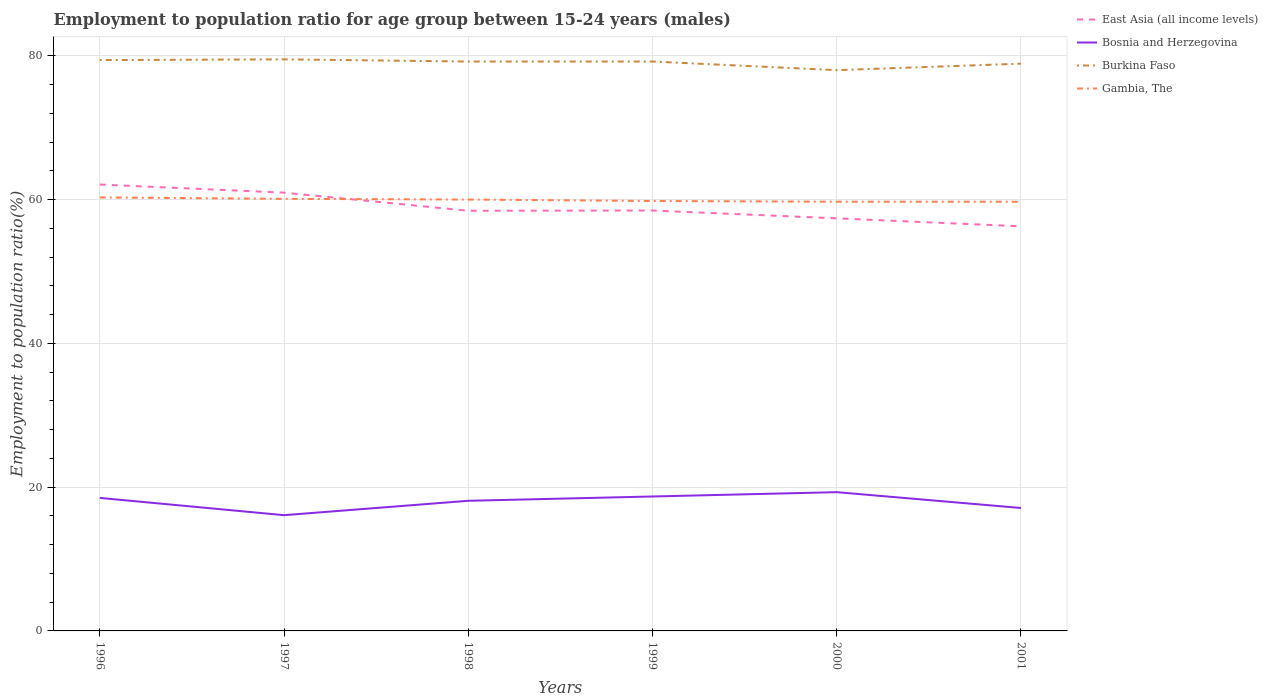How many different coloured lines are there?
Make the answer very short. 4. Across all years, what is the maximum employment to population ratio in Burkina Faso?
Your answer should be very brief. 78. What is the total employment to population ratio in East Asia (all income levels) in the graph?
Your response must be concise. 2.49. What is the difference between the highest and the second highest employment to population ratio in Bosnia and Herzegovina?
Give a very brief answer. 3.2. What is the difference between two consecutive major ticks on the Y-axis?
Ensure brevity in your answer.  20. Are the values on the major ticks of Y-axis written in scientific E-notation?
Ensure brevity in your answer.  No. Does the graph contain any zero values?
Your answer should be very brief. No. Does the graph contain grids?
Your answer should be very brief. Yes. Where does the legend appear in the graph?
Your answer should be compact. Top right. How many legend labels are there?
Your answer should be very brief. 4. How are the legend labels stacked?
Keep it short and to the point. Vertical. What is the title of the graph?
Your response must be concise. Employment to population ratio for age group between 15-24 years (males). What is the label or title of the Y-axis?
Offer a terse response. Employment to population ratio(%). What is the Employment to population ratio(%) in East Asia (all income levels) in 1996?
Provide a succinct answer. 62.09. What is the Employment to population ratio(%) in Burkina Faso in 1996?
Your response must be concise. 79.4. What is the Employment to population ratio(%) in Gambia, The in 1996?
Provide a succinct answer. 60.3. What is the Employment to population ratio(%) of East Asia (all income levels) in 1997?
Your answer should be very brief. 60.96. What is the Employment to population ratio(%) of Bosnia and Herzegovina in 1997?
Offer a very short reply. 16.1. What is the Employment to population ratio(%) of Burkina Faso in 1997?
Offer a terse response. 79.5. What is the Employment to population ratio(%) in Gambia, The in 1997?
Make the answer very short. 60.1. What is the Employment to population ratio(%) of East Asia (all income levels) in 1998?
Keep it short and to the point. 58.44. What is the Employment to population ratio(%) in Bosnia and Herzegovina in 1998?
Make the answer very short. 18.1. What is the Employment to population ratio(%) of Burkina Faso in 1998?
Provide a succinct answer. 79.2. What is the Employment to population ratio(%) of Gambia, The in 1998?
Provide a succinct answer. 60. What is the Employment to population ratio(%) of East Asia (all income levels) in 1999?
Provide a short and direct response. 58.47. What is the Employment to population ratio(%) in Bosnia and Herzegovina in 1999?
Your response must be concise. 18.7. What is the Employment to population ratio(%) of Burkina Faso in 1999?
Keep it short and to the point. 79.2. What is the Employment to population ratio(%) of Gambia, The in 1999?
Offer a very short reply. 59.8. What is the Employment to population ratio(%) of East Asia (all income levels) in 2000?
Provide a succinct answer. 57.39. What is the Employment to population ratio(%) of Bosnia and Herzegovina in 2000?
Give a very brief answer. 19.3. What is the Employment to population ratio(%) in Gambia, The in 2000?
Provide a succinct answer. 59.7. What is the Employment to population ratio(%) in East Asia (all income levels) in 2001?
Give a very brief answer. 56.28. What is the Employment to population ratio(%) of Bosnia and Herzegovina in 2001?
Make the answer very short. 17.1. What is the Employment to population ratio(%) in Burkina Faso in 2001?
Ensure brevity in your answer.  78.9. What is the Employment to population ratio(%) in Gambia, The in 2001?
Your response must be concise. 59.7. Across all years, what is the maximum Employment to population ratio(%) in East Asia (all income levels)?
Make the answer very short. 62.09. Across all years, what is the maximum Employment to population ratio(%) in Bosnia and Herzegovina?
Offer a very short reply. 19.3. Across all years, what is the maximum Employment to population ratio(%) of Burkina Faso?
Ensure brevity in your answer.  79.5. Across all years, what is the maximum Employment to population ratio(%) of Gambia, The?
Your answer should be very brief. 60.3. Across all years, what is the minimum Employment to population ratio(%) of East Asia (all income levels)?
Provide a succinct answer. 56.28. Across all years, what is the minimum Employment to population ratio(%) in Bosnia and Herzegovina?
Ensure brevity in your answer.  16.1. Across all years, what is the minimum Employment to population ratio(%) of Gambia, The?
Your response must be concise. 59.7. What is the total Employment to population ratio(%) of East Asia (all income levels) in the graph?
Your answer should be very brief. 353.63. What is the total Employment to population ratio(%) of Bosnia and Herzegovina in the graph?
Your answer should be very brief. 107.8. What is the total Employment to population ratio(%) of Burkina Faso in the graph?
Your answer should be very brief. 474.2. What is the total Employment to population ratio(%) in Gambia, The in the graph?
Provide a short and direct response. 359.6. What is the difference between the Employment to population ratio(%) in East Asia (all income levels) in 1996 and that in 1997?
Make the answer very short. 1.13. What is the difference between the Employment to population ratio(%) of Bosnia and Herzegovina in 1996 and that in 1997?
Offer a terse response. 2.4. What is the difference between the Employment to population ratio(%) of Burkina Faso in 1996 and that in 1997?
Make the answer very short. -0.1. What is the difference between the Employment to population ratio(%) in East Asia (all income levels) in 1996 and that in 1998?
Provide a succinct answer. 3.65. What is the difference between the Employment to population ratio(%) of Bosnia and Herzegovina in 1996 and that in 1998?
Your answer should be very brief. 0.4. What is the difference between the Employment to population ratio(%) in East Asia (all income levels) in 1996 and that in 1999?
Your answer should be very brief. 3.62. What is the difference between the Employment to population ratio(%) of Burkina Faso in 1996 and that in 1999?
Provide a short and direct response. 0.2. What is the difference between the Employment to population ratio(%) in East Asia (all income levels) in 1996 and that in 2000?
Provide a succinct answer. 4.7. What is the difference between the Employment to population ratio(%) in Gambia, The in 1996 and that in 2000?
Provide a short and direct response. 0.6. What is the difference between the Employment to population ratio(%) of East Asia (all income levels) in 1996 and that in 2001?
Your answer should be very brief. 5.81. What is the difference between the Employment to population ratio(%) of Gambia, The in 1996 and that in 2001?
Your answer should be compact. 0.6. What is the difference between the Employment to population ratio(%) in East Asia (all income levels) in 1997 and that in 1998?
Provide a succinct answer. 2.52. What is the difference between the Employment to population ratio(%) of East Asia (all income levels) in 1997 and that in 1999?
Your answer should be compact. 2.49. What is the difference between the Employment to population ratio(%) in Burkina Faso in 1997 and that in 1999?
Your response must be concise. 0.3. What is the difference between the Employment to population ratio(%) in Gambia, The in 1997 and that in 1999?
Provide a short and direct response. 0.3. What is the difference between the Employment to population ratio(%) of East Asia (all income levels) in 1997 and that in 2000?
Ensure brevity in your answer.  3.57. What is the difference between the Employment to population ratio(%) of Burkina Faso in 1997 and that in 2000?
Provide a succinct answer. 1.5. What is the difference between the Employment to population ratio(%) of East Asia (all income levels) in 1997 and that in 2001?
Ensure brevity in your answer.  4.68. What is the difference between the Employment to population ratio(%) of Bosnia and Herzegovina in 1997 and that in 2001?
Make the answer very short. -1. What is the difference between the Employment to population ratio(%) in East Asia (all income levels) in 1998 and that in 1999?
Your answer should be very brief. -0.03. What is the difference between the Employment to population ratio(%) in East Asia (all income levels) in 1998 and that in 2000?
Give a very brief answer. 1.06. What is the difference between the Employment to population ratio(%) in Bosnia and Herzegovina in 1998 and that in 2000?
Offer a very short reply. -1.2. What is the difference between the Employment to population ratio(%) in East Asia (all income levels) in 1998 and that in 2001?
Keep it short and to the point. 2.17. What is the difference between the Employment to population ratio(%) in Burkina Faso in 1998 and that in 2001?
Provide a short and direct response. 0.3. What is the difference between the Employment to population ratio(%) in Gambia, The in 1998 and that in 2001?
Your response must be concise. 0.3. What is the difference between the Employment to population ratio(%) of East Asia (all income levels) in 1999 and that in 2000?
Give a very brief answer. 1.09. What is the difference between the Employment to population ratio(%) of Burkina Faso in 1999 and that in 2000?
Your answer should be very brief. 1.2. What is the difference between the Employment to population ratio(%) of Gambia, The in 1999 and that in 2000?
Your answer should be very brief. 0.1. What is the difference between the Employment to population ratio(%) of East Asia (all income levels) in 1999 and that in 2001?
Offer a terse response. 2.2. What is the difference between the Employment to population ratio(%) of Burkina Faso in 1999 and that in 2001?
Ensure brevity in your answer.  0.3. What is the difference between the Employment to population ratio(%) of Gambia, The in 1999 and that in 2001?
Give a very brief answer. 0.1. What is the difference between the Employment to population ratio(%) in East Asia (all income levels) in 2000 and that in 2001?
Make the answer very short. 1.11. What is the difference between the Employment to population ratio(%) of Burkina Faso in 2000 and that in 2001?
Offer a very short reply. -0.9. What is the difference between the Employment to population ratio(%) of East Asia (all income levels) in 1996 and the Employment to population ratio(%) of Bosnia and Herzegovina in 1997?
Ensure brevity in your answer.  45.99. What is the difference between the Employment to population ratio(%) of East Asia (all income levels) in 1996 and the Employment to population ratio(%) of Burkina Faso in 1997?
Your answer should be very brief. -17.41. What is the difference between the Employment to population ratio(%) in East Asia (all income levels) in 1996 and the Employment to population ratio(%) in Gambia, The in 1997?
Your answer should be very brief. 1.99. What is the difference between the Employment to population ratio(%) of Bosnia and Herzegovina in 1996 and the Employment to population ratio(%) of Burkina Faso in 1997?
Provide a succinct answer. -61. What is the difference between the Employment to population ratio(%) of Bosnia and Herzegovina in 1996 and the Employment to population ratio(%) of Gambia, The in 1997?
Make the answer very short. -41.6. What is the difference between the Employment to population ratio(%) in Burkina Faso in 1996 and the Employment to population ratio(%) in Gambia, The in 1997?
Give a very brief answer. 19.3. What is the difference between the Employment to population ratio(%) of East Asia (all income levels) in 1996 and the Employment to population ratio(%) of Bosnia and Herzegovina in 1998?
Your answer should be compact. 43.99. What is the difference between the Employment to population ratio(%) in East Asia (all income levels) in 1996 and the Employment to population ratio(%) in Burkina Faso in 1998?
Make the answer very short. -17.11. What is the difference between the Employment to population ratio(%) of East Asia (all income levels) in 1996 and the Employment to population ratio(%) of Gambia, The in 1998?
Your response must be concise. 2.09. What is the difference between the Employment to population ratio(%) of Bosnia and Herzegovina in 1996 and the Employment to population ratio(%) of Burkina Faso in 1998?
Ensure brevity in your answer.  -60.7. What is the difference between the Employment to population ratio(%) of Bosnia and Herzegovina in 1996 and the Employment to population ratio(%) of Gambia, The in 1998?
Offer a very short reply. -41.5. What is the difference between the Employment to population ratio(%) of Burkina Faso in 1996 and the Employment to population ratio(%) of Gambia, The in 1998?
Make the answer very short. 19.4. What is the difference between the Employment to population ratio(%) of East Asia (all income levels) in 1996 and the Employment to population ratio(%) of Bosnia and Herzegovina in 1999?
Keep it short and to the point. 43.39. What is the difference between the Employment to population ratio(%) in East Asia (all income levels) in 1996 and the Employment to population ratio(%) in Burkina Faso in 1999?
Make the answer very short. -17.11. What is the difference between the Employment to population ratio(%) of East Asia (all income levels) in 1996 and the Employment to population ratio(%) of Gambia, The in 1999?
Your response must be concise. 2.29. What is the difference between the Employment to population ratio(%) in Bosnia and Herzegovina in 1996 and the Employment to population ratio(%) in Burkina Faso in 1999?
Your answer should be very brief. -60.7. What is the difference between the Employment to population ratio(%) in Bosnia and Herzegovina in 1996 and the Employment to population ratio(%) in Gambia, The in 1999?
Give a very brief answer. -41.3. What is the difference between the Employment to population ratio(%) of Burkina Faso in 1996 and the Employment to population ratio(%) of Gambia, The in 1999?
Your answer should be very brief. 19.6. What is the difference between the Employment to population ratio(%) of East Asia (all income levels) in 1996 and the Employment to population ratio(%) of Bosnia and Herzegovina in 2000?
Ensure brevity in your answer.  42.79. What is the difference between the Employment to population ratio(%) of East Asia (all income levels) in 1996 and the Employment to population ratio(%) of Burkina Faso in 2000?
Your answer should be compact. -15.91. What is the difference between the Employment to population ratio(%) in East Asia (all income levels) in 1996 and the Employment to population ratio(%) in Gambia, The in 2000?
Give a very brief answer. 2.39. What is the difference between the Employment to population ratio(%) in Bosnia and Herzegovina in 1996 and the Employment to population ratio(%) in Burkina Faso in 2000?
Your answer should be compact. -59.5. What is the difference between the Employment to population ratio(%) of Bosnia and Herzegovina in 1996 and the Employment to population ratio(%) of Gambia, The in 2000?
Offer a very short reply. -41.2. What is the difference between the Employment to population ratio(%) in East Asia (all income levels) in 1996 and the Employment to population ratio(%) in Bosnia and Herzegovina in 2001?
Your answer should be compact. 44.99. What is the difference between the Employment to population ratio(%) in East Asia (all income levels) in 1996 and the Employment to population ratio(%) in Burkina Faso in 2001?
Your answer should be compact. -16.81. What is the difference between the Employment to population ratio(%) of East Asia (all income levels) in 1996 and the Employment to population ratio(%) of Gambia, The in 2001?
Ensure brevity in your answer.  2.39. What is the difference between the Employment to population ratio(%) of Bosnia and Herzegovina in 1996 and the Employment to population ratio(%) of Burkina Faso in 2001?
Your answer should be very brief. -60.4. What is the difference between the Employment to population ratio(%) in Bosnia and Herzegovina in 1996 and the Employment to population ratio(%) in Gambia, The in 2001?
Offer a very short reply. -41.2. What is the difference between the Employment to population ratio(%) of East Asia (all income levels) in 1997 and the Employment to population ratio(%) of Bosnia and Herzegovina in 1998?
Make the answer very short. 42.86. What is the difference between the Employment to population ratio(%) in East Asia (all income levels) in 1997 and the Employment to population ratio(%) in Burkina Faso in 1998?
Provide a short and direct response. -18.24. What is the difference between the Employment to population ratio(%) in East Asia (all income levels) in 1997 and the Employment to population ratio(%) in Gambia, The in 1998?
Provide a short and direct response. 0.96. What is the difference between the Employment to population ratio(%) of Bosnia and Herzegovina in 1997 and the Employment to population ratio(%) of Burkina Faso in 1998?
Your answer should be compact. -63.1. What is the difference between the Employment to population ratio(%) in Bosnia and Herzegovina in 1997 and the Employment to population ratio(%) in Gambia, The in 1998?
Ensure brevity in your answer.  -43.9. What is the difference between the Employment to population ratio(%) of East Asia (all income levels) in 1997 and the Employment to population ratio(%) of Bosnia and Herzegovina in 1999?
Your response must be concise. 42.26. What is the difference between the Employment to population ratio(%) in East Asia (all income levels) in 1997 and the Employment to population ratio(%) in Burkina Faso in 1999?
Ensure brevity in your answer.  -18.24. What is the difference between the Employment to population ratio(%) of East Asia (all income levels) in 1997 and the Employment to population ratio(%) of Gambia, The in 1999?
Keep it short and to the point. 1.16. What is the difference between the Employment to population ratio(%) in Bosnia and Herzegovina in 1997 and the Employment to population ratio(%) in Burkina Faso in 1999?
Provide a short and direct response. -63.1. What is the difference between the Employment to population ratio(%) in Bosnia and Herzegovina in 1997 and the Employment to population ratio(%) in Gambia, The in 1999?
Ensure brevity in your answer.  -43.7. What is the difference between the Employment to population ratio(%) in Burkina Faso in 1997 and the Employment to population ratio(%) in Gambia, The in 1999?
Ensure brevity in your answer.  19.7. What is the difference between the Employment to population ratio(%) of East Asia (all income levels) in 1997 and the Employment to population ratio(%) of Bosnia and Herzegovina in 2000?
Offer a terse response. 41.66. What is the difference between the Employment to population ratio(%) of East Asia (all income levels) in 1997 and the Employment to population ratio(%) of Burkina Faso in 2000?
Provide a succinct answer. -17.04. What is the difference between the Employment to population ratio(%) of East Asia (all income levels) in 1997 and the Employment to population ratio(%) of Gambia, The in 2000?
Give a very brief answer. 1.26. What is the difference between the Employment to population ratio(%) in Bosnia and Herzegovina in 1997 and the Employment to population ratio(%) in Burkina Faso in 2000?
Provide a short and direct response. -61.9. What is the difference between the Employment to population ratio(%) in Bosnia and Herzegovina in 1997 and the Employment to population ratio(%) in Gambia, The in 2000?
Provide a short and direct response. -43.6. What is the difference between the Employment to population ratio(%) in Burkina Faso in 1997 and the Employment to population ratio(%) in Gambia, The in 2000?
Your answer should be very brief. 19.8. What is the difference between the Employment to population ratio(%) of East Asia (all income levels) in 1997 and the Employment to population ratio(%) of Bosnia and Herzegovina in 2001?
Your response must be concise. 43.86. What is the difference between the Employment to population ratio(%) in East Asia (all income levels) in 1997 and the Employment to population ratio(%) in Burkina Faso in 2001?
Keep it short and to the point. -17.94. What is the difference between the Employment to population ratio(%) in East Asia (all income levels) in 1997 and the Employment to population ratio(%) in Gambia, The in 2001?
Offer a terse response. 1.26. What is the difference between the Employment to population ratio(%) in Bosnia and Herzegovina in 1997 and the Employment to population ratio(%) in Burkina Faso in 2001?
Your response must be concise. -62.8. What is the difference between the Employment to population ratio(%) in Bosnia and Herzegovina in 1997 and the Employment to population ratio(%) in Gambia, The in 2001?
Give a very brief answer. -43.6. What is the difference between the Employment to population ratio(%) in Burkina Faso in 1997 and the Employment to population ratio(%) in Gambia, The in 2001?
Your answer should be compact. 19.8. What is the difference between the Employment to population ratio(%) in East Asia (all income levels) in 1998 and the Employment to population ratio(%) in Bosnia and Herzegovina in 1999?
Ensure brevity in your answer.  39.74. What is the difference between the Employment to population ratio(%) of East Asia (all income levels) in 1998 and the Employment to population ratio(%) of Burkina Faso in 1999?
Keep it short and to the point. -20.76. What is the difference between the Employment to population ratio(%) of East Asia (all income levels) in 1998 and the Employment to population ratio(%) of Gambia, The in 1999?
Your response must be concise. -1.36. What is the difference between the Employment to population ratio(%) in Bosnia and Herzegovina in 1998 and the Employment to population ratio(%) in Burkina Faso in 1999?
Provide a succinct answer. -61.1. What is the difference between the Employment to population ratio(%) of Bosnia and Herzegovina in 1998 and the Employment to population ratio(%) of Gambia, The in 1999?
Keep it short and to the point. -41.7. What is the difference between the Employment to population ratio(%) in East Asia (all income levels) in 1998 and the Employment to population ratio(%) in Bosnia and Herzegovina in 2000?
Your response must be concise. 39.14. What is the difference between the Employment to population ratio(%) of East Asia (all income levels) in 1998 and the Employment to population ratio(%) of Burkina Faso in 2000?
Your answer should be compact. -19.56. What is the difference between the Employment to population ratio(%) of East Asia (all income levels) in 1998 and the Employment to population ratio(%) of Gambia, The in 2000?
Offer a terse response. -1.26. What is the difference between the Employment to population ratio(%) in Bosnia and Herzegovina in 1998 and the Employment to population ratio(%) in Burkina Faso in 2000?
Provide a short and direct response. -59.9. What is the difference between the Employment to population ratio(%) in Bosnia and Herzegovina in 1998 and the Employment to population ratio(%) in Gambia, The in 2000?
Your answer should be compact. -41.6. What is the difference between the Employment to population ratio(%) in East Asia (all income levels) in 1998 and the Employment to population ratio(%) in Bosnia and Herzegovina in 2001?
Ensure brevity in your answer.  41.34. What is the difference between the Employment to population ratio(%) of East Asia (all income levels) in 1998 and the Employment to population ratio(%) of Burkina Faso in 2001?
Provide a short and direct response. -20.46. What is the difference between the Employment to population ratio(%) of East Asia (all income levels) in 1998 and the Employment to population ratio(%) of Gambia, The in 2001?
Your answer should be very brief. -1.26. What is the difference between the Employment to population ratio(%) in Bosnia and Herzegovina in 1998 and the Employment to population ratio(%) in Burkina Faso in 2001?
Give a very brief answer. -60.8. What is the difference between the Employment to population ratio(%) in Bosnia and Herzegovina in 1998 and the Employment to population ratio(%) in Gambia, The in 2001?
Make the answer very short. -41.6. What is the difference between the Employment to population ratio(%) of Burkina Faso in 1998 and the Employment to population ratio(%) of Gambia, The in 2001?
Provide a succinct answer. 19.5. What is the difference between the Employment to population ratio(%) of East Asia (all income levels) in 1999 and the Employment to population ratio(%) of Bosnia and Herzegovina in 2000?
Offer a very short reply. 39.17. What is the difference between the Employment to population ratio(%) of East Asia (all income levels) in 1999 and the Employment to population ratio(%) of Burkina Faso in 2000?
Ensure brevity in your answer.  -19.53. What is the difference between the Employment to population ratio(%) of East Asia (all income levels) in 1999 and the Employment to population ratio(%) of Gambia, The in 2000?
Offer a terse response. -1.23. What is the difference between the Employment to population ratio(%) in Bosnia and Herzegovina in 1999 and the Employment to population ratio(%) in Burkina Faso in 2000?
Offer a very short reply. -59.3. What is the difference between the Employment to population ratio(%) of Bosnia and Herzegovina in 1999 and the Employment to population ratio(%) of Gambia, The in 2000?
Make the answer very short. -41. What is the difference between the Employment to population ratio(%) of East Asia (all income levels) in 1999 and the Employment to population ratio(%) of Bosnia and Herzegovina in 2001?
Ensure brevity in your answer.  41.37. What is the difference between the Employment to population ratio(%) in East Asia (all income levels) in 1999 and the Employment to population ratio(%) in Burkina Faso in 2001?
Your answer should be very brief. -20.43. What is the difference between the Employment to population ratio(%) of East Asia (all income levels) in 1999 and the Employment to population ratio(%) of Gambia, The in 2001?
Make the answer very short. -1.23. What is the difference between the Employment to population ratio(%) in Bosnia and Herzegovina in 1999 and the Employment to population ratio(%) in Burkina Faso in 2001?
Provide a succinct answer. -60.2. What is the difference between the Employment to population ratio(%) in Bosnia and Herzegovina in 1999 and the Employment to population ratio(%) in Gambia, The in 2001?
Make the answer very short. -41. What is the difference between the Employment to population ratio(%) of Burkina Faso in 1999 and the Employment to population ratio(%) of Gambia, The in 2001?
Provide a succinct answer. 19.5. What is the difference between the Employment to population ratio(%) in East Asia (all income levels) in 2000 and the Employment to population ratio(%) in Bosnia and Herzegovina in 2001?
Make the answer very short. 40.29. What is the difference between the Employment to population ratio(%) of East Asia (all income levels) in 2000 and the Employment to population ratio(%) of Burkina Faso in 2001?
Keep it short and to the point. -21.51. What is the difference between the Employment to population ratio(%) in East Asia (all income levels) in 2000 and the Employment to population ratio(%) in Gambia, The in 2001?
Provide a short and direct response. -2.31. What is the difference between the Employment to population ratio(%) in Bosnia and Herzegovina in 2000 and the Employment to population ratio(%) in Burkina Faso in 2001?
Your response must be concise. -59.6. What is the difference between the Employment to population ratio(%) of Bosnia and Herzegovina in 2000 and the Employment to population ratio(%) of Gambia, The in 2001?
Make the answer very short. -40.4. What is the difference between the Employment to population ratio(%) of Burkina Faso in 2000 and the Employment to population ratio(%) of Gambia, The in 2001?
Your answer should be very brief. 18.3. What is the average Employment to population ratio(%) of East Asia (all income levels) per year?
Your response must be concise. 58.94. What is the average Employment to population ratio(%) of Bosnia and Herzegovina per year?
Offer a very short reply. 17.97. What is the average Employment to population ratio(%) of Burkina Faso per year?
Ensure brevity in your answer.  79.03. What is the average Employment to population ratio(%) of Gambia, The per year?
Keep it short and to the point. 59.93. In the year 1996, what is the difference between the Employment to population ratio(%) in East Asia (all income levels) and Employment to population ratio(%) in Bosnia and Herzegovina?
Ensure brevity in your answer.  43.59. In the year 1996, what is the difference between the Employment to population ratio(%) in East Asia (all income levels) and Employment to population ratio(%) in Burkina Faso?
Offer a very short reply. -17.31. In the year 1996, what is the difference between the Employment to population ratio(%) of East Asia (all income levels) and Employment to population ratio(%) of Gambia, The?
Offer a very short reply. 1.79. In the year 1996, what is the difference between the Employment to population ratio(%) in Bosnia and Herzegovina and Employment to population ratio(%) in Burkina Faso?
Give a very brief answer. -60.9. In the year 1996, what is the difference between the Employment to population ratio(%) of Bosnia and Herzegovina and Employment to population ratio(%) of Gambia, The?
Your answer should be very brief. -41.8. In the year 1996, what is the difference between the Employment to population ratio(%) of Burkina Faso and Employment to population ratio(%) of Gambia, The?
Make the answer very short. 19.1. In the year 1997, what is the difference between the Employment to population ratio(%) of East Asia (all income levels) and Employment to population ratio(%) of Bosnia and Herzegovina?
Your answer should be compact. 44.86. In the year 1997, what is the difference between the Employment to population ratio(%) in East Asia (all income levels) and Employment to population ratio(%) in Burkina Faso?
Ensure brevity in your answer.  -18.54. In the year 1997, what is the difference between the Employment to population ratio(%) of East Asia (all income levels) and Employment to population ratio(%) of Gambia, The?
Provide a short and direct response. 0.86. In the year 1997, what is the difference between the Employment to population ratio(%) in Bosnia and Herzegovina and Employment to population ratio(%) in Burkina Faso?
Your answer should be very brief. -63.4. In the year 1997, what is the difference between the Employment to population ratio(%) of Bosnia and Herzegovina and Employment to population ratio(%) of Gambia, The?
Provide a succinct answer. -44. In the year 1998, what is the difference between the Employment to population ratio(%) in East Asia (all income levels) and Employment to population ratio(%) in Bosnia and Herzegovina?
Provide a succinct answer. 40.34. In the year 1998, what is the difference between the Employment to population ratio(%) of East Asia (all income levels) and Employment to population ratio(%) of Burkina Faso?
Offer a terse response. -20.76. In the year 1998, what is the difference between the Employment to population ratio(%) in East Asia (all income levels) and Employment to population ratio(%) in Gambia, The?
Keep it short and to the point. -1.56. In the year 1998, what is the difference between the Employment to population ratio(%) in Bosnia and Herzegovina and Employment to population ratio(%) in Burkina Faso?
Offer a terse response. -61.1. In the year 1998, what is the difference between the Employment to population ratio(%) of Bosnia and Herzegovina and Employment to population ratio(%) of Gambia, The?
Provide a succinct answer. -41.9. In the year 1998, what is the difference between the Employment to population ratio(%) in Burkina Faso and Employment to population ratio(%) in Gambia, The?
Make the answer very short. 19.2. In the year 1999, what is the difference between the Employment to population ratio(%) in East Asia (all income levels) and Employment to population ratio(%) in Bosnia and Herzegovina?
Your response must be concise. 39.77. In the year 1999, what is the difference between the Employment to population ratio(%) in East Asia (all income levels) and Employment to population ratio(%) in Burkina Faso?
Offer a very short reply. -20.73. In the year 1999, what is the difference between the Employment to population ratio(%) in East Asia (all income levels) and Employment to population ratio(%) in Gambia, The?
Your answer should be very brief. -1.33. In the year 1999, what is the difference between the Employment to population ratio(%) of Bosnia and Herzegovina and Employment to population ratio(%) of Burkina Faso?
Your response must be concise. -60.5. In the year 1999, what is the difference between the Employment to population ratio(%) in Bosnia and Herzegovina and Employment to population ratio(%) in Gambia, The?
Ensure brevity in your answer.  -41.1. In the year 1999, what is the difference between the Employment to population ratio(%) in Burkina Faso and Employment to population ratio(%) in Gambia, The?
Offer a terse response. 19.4. In the year 2000, what is the difference between the Employment to population ratio(%) in East Asia (all income levels) and Employment to population ratio(%) in Bosnia and Herzegovina?
Your answer should be very brief. 38.09. In the year 2000, what is the difference between the Employment to population ratio(%) in East Asia (all income levels) and Employment to population ratio(%) in Burkina Faso?
Your answer should be compact. -20.61. In the year 2000, what is the difference between the Employment to population ratio(%) of East Asia (all income levels) and Employment to population ratio(%) of Gambia, The?
Keep it short and to the point. -2.31. In the year 2000, what is the difference between the Employment to population ratio(%) of Bosnia and Herzegovina and Employment to population ratio(%) of Burkina Faso?
Provide a short and direct response. -58.7. In the year 2000, what is the difference between the Employment to population ratio(%) in Bosnia and Herzegovina and Employment to population ratio(%) in Gambia, The?
Keep it short and to the point. -40.4. In the year 2000, what is the difference between the Employment to population ratio(%) of Burkina Faso and Employment to population ratio(%) of Gambia, The?
Keep it short and to the point. 18.3. In the year 2001, what is the difference between the Employment to population ratio(%) of East Asia (all income levels) and Employment to population ratio(%) of Bosnia and Herzegovina?
Your response must be concise. 39.18. In the year 2001, what is the difference between the Employment to population ratio(%) of East Asia (all income levels) and Employment to population ratio(%) of Burkina Faso?
Your answer should be compact. -22.62. In the year 2001, what is the difference between the Employment to population ratio(%) of East Asia (all income levels) and Employment to population ratio(%) of Gambia, The?
Your answer should be very brief. -3.42. In the year 2001, what is the difference between the Employment to population ratio(%) in Bosnia and Herzegovina and Employment to population ratio(%) in Burkina Faso?
Your answer should be compact. -61.8. In the year 2001, what is the difference between the Employment to population ratio(%) of Bosnia and Herzegovina and Employment to population ratio(%) of Gambia, The?
Keep it short and to the point. -42.6. What is the ratio of the Employment to population ratio(%) of East Asia (all income levels) in 1996 to that in 1997?
Your answer should be very brief. 1.02. What is the ratio of the Employment to population ratio(%) of Bosnia and Herzegovina in 1996 to that in 1997?
Provide a succinct answer. 1.15. What is the ratio of the Employment to population ratio(%) in Burkina Faso in 1996 to that in 1997?
Your response must be concise. 1. What is the ratio of the Employment to population ratio(%) in Gambia, The in 1996 to that in 1997?
Ensure brevity in your answer.  1. What is the ratio of the Employment to population ratio(%) in East Asia (all income levels) in 1996 to that in 1998?
Your answer should be very brief. 1.06. What is the ratio of the Employment to population ratio(%) in Bosnia and Herzegovina in 1996 to that in 1998?
Your answer should be very brief. 1.02. What is the ratio of the Employment to population ratio(%) in Gambia, The in 1996 to that in 1998?
Your answer should be compact. 1. What is the ratio of the Employment to population ratio(%) of East Asia (all income levels) in 1996 to that in 1999?
Your response must be concise. 1.06. What is the ratio of the Employment to population ratio(%) in Bosnia and Herzegovina in 1996 to that in 1999?
Your answer should be compact. 0.99. What is the ratio of the Employment to population ratio(%) of Gambia, The in 1996 to that in 1999?
Offer a terse response. 1.01. What is the ratio of the Employment to population ratio(%) of East Asia (all income levels) in 1996 to that in 2000?
Make the answer very short. 1.08. What is the ratio of the Employment to population ratio(%) of Bosnia and Herzegovina in 1996 to that in 2000?
Provide a short and direct response. 0.96. What is the ratio of the Employment to population ratio(%) in Burkina Faso in 1996 to that in 2000?
Your answer should be very brief. 1.02. What is the ratio of the Employment to population ratio(%) in East Asia (all income levels) in 1996 to that in 2001?
Make the answer very short. 1.1. What is the ratio of the Employment to population ratio(%) of Bosnia and Herzegovina in 1996 to that in 2001?
Your response must be concise. 1.08. What is the ratio of the Employment to population ratio(%) in East Asia (all income levels) in 1997 to that in 1998?
Ensure brevity in your answer.  1.04. What is the ratio of the Employment to population ratio(%) in Bosnia and Herzegovina in 1997 to that in 1998?
Make the answer very short. 0.89. What is the ratio of the Employment to population ratio(%) in Burkina Faso in 1997 to that in 1998?
Your response must be concise. 1. What is the ratio of the Employment to population ratio(%) of Gambia, The in 1997 to that in 1998?
Provide a short and direct response. 1. What is the ratio of the Employment to population ratio(%) of East Asia (all income levels) in 1997 to that in 1999?
Your response must be concise. 1.04. What is the ratio of the Employment to population ratio(%) in Bosnia and Herzegovina in 1997 to that in 1999?
Offer a very short reply. 0.86. What is the ratio of the Employment to population ratio(%) in Burkina Faso in 1997 to that in 1999?
Give a very brief answer. 1. What is the ratio of the Employment to population ratio(%) of Gambia, The in 1997 to that in 1999?
Offer a very short reply. 1. What is the ratio of the Employment to population ratio(%) in East Asia (all income levels) in 1997 to that in 2000?
Your answer should be compact. 1.06. What is the ratio of the Employment to population ratio(%) of Bosnia and Herzegovina in 1997 to that in 2000?
Your answer should be compact. 0.83. What is the ratio of the Employment to population ratio(%) in Burkina Faso in 1997 to that in 2000?
Your answer should be very brief. 1.02. What is the ratio of the Employment to population ratio(%) in Gambia, The in 1997 to that in 2000?
Your answer should be compact. 1.01. What is the ratio of the Employment to population ratio(%) of East Asia (all income levels) in 1997 to that in 2001?
Provide a short and direct response. 1.08. What is the ratio of the Employment to population ratio(%) in Bosnia and Herzegovina in 1997 to that in 2001?
Offer a terse response. 0.94. What is the ratio of the Employment to population ratio(%) of Burkina Faso in 1997 to that in 2001?
Provide a short and direct response. 1.01. What is the ratio of the Employment to population ratio(%) in Gambia, The in 1997 to that in 2001?
Offer a very short reply. 1.01. What is the ratio of the Employment to population ratio(%) of East Asia (all income levels) in 1998 to that in 1999?
Your answer should be compact. 1. What is the ratio of the Employment to population ratio(%) of Bosnia and Herzegovina in 1998 to that in 1999?
Keep it short and to the point. 0.97. What is the ratio of the Employment to population ratio(%) in East Asia (all income levels) in 1998 to that in 2000?
Provide a succinct answer. 1.02. What is the ratio of the Employment to population ratio(%) of Bosnia and Herzegovina in 1998 to that in 2000?
Offer a very short reply. 0.94. What is the ratio of the Employment to population ratio(%) in Burkina Faso in 1998 to that in 2000?
Provide a short and direct response. 1.02. What is the ratio of the Employment to population ratio(%) in East Asia (all income levels) in 1998 to that in 2001?
Provide a succinct answer. 1.04. What is the ratio of the Employment to population ratio(%) in Bosnia and Herzegovina in 1998 to that in 2001?
Your answer should be compact. 1.06. What is the ratio of the Employment to population ratio(%) of Burkina Faso in 1998 to that in 2001?
Your answer should be very brief. 1. What is the ratio of the Employment to population ratio(%) of East Asia (all income levels) in 1999 to that in 2000?
Your response must be concise. 1.02. What is the ratio of the Employment to population ratio(%) of Bosnia and Herzegovina in 1999 to that in 2000?
Your response must be concise. 0.97. What is the ratio of the Employment to population ratio(%) in Burkina Faso in 1999 to that in 2000?
Your answer should be compact. 1.02. What is the ratio of the Employment to population ratio(%) in Gambia, The in 1999 to that in 2000?
Make the answer very short. 1. What is the ratio of the Employment to population ratio(%) of East Asia (all income levels) in 1999 to that in 2001?
Make the answer very short. 1.04. What is the ratio of the Employment to population ratio(%) of Bosnia and Herzegovina in 1999 to that in 2001?
Keep it short and to the point. 1.09. What is the ratio of the Employment to population ratio(%) of Gambia, The in 1999 to that in 2001?
Provide a short and direct response. 1. What is the ratio of the Employment to population ratio(%) in East Asia (all income levels) in 2000 to that in 2001?
Provide a short and direct response. 1.02. What is the ratio of the Employment to population ratio(%) in Bosnia and Herzegovina in 2000 to that in 2001?
Provide a short and direct response. 1.13. What is the ratio of the Employment to population ratio(%) in Gambia, The in 2000 to that in 2001?
Provide a succinct answer. 1. What is the difference between the highest and the second highest Employment to population ratio(%) of East Asia (all income levels)?
Your response must be concise. 1.13. What is the difference between the highest and the second highest Employment to population ratio(%) of Bosnia and Herzegovina?
Offer a very short reply. 0.6. What is the difference between the highest and the lowest Employment to population ratio(%) of East Asia (all income levels)?
Your answer should be compact. 5.81. What is the difference between the highest and the lowest Employment to population ratio(%) in Bosnia and Herzegovina?
Make the answer very short. 3.2. What is the difference between the highest and the lowest Employment to population ratio(%) of Gambia, The?
Provide a short and direct response. 0.6. 